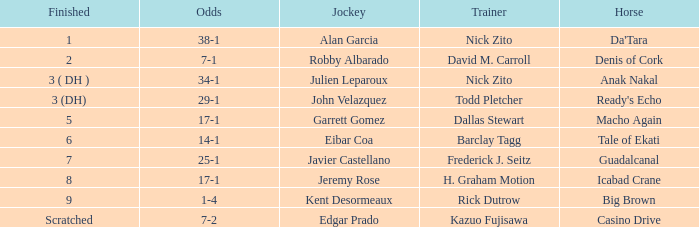What are the Odds for the Horse called Ready's Echo? 29-1. Could you help me parse every detail presented in this table? {'header': ['Finished', 'Odds', 'Jockey', 'Trainer', 'Horse'], 'rows': [['1', '38-1', 'Alan Garcia', 'Nick Zito', "Da'Tara"], ['2', '7-1', 'Robby Albarado', 'David M. Carroll', 'Denis of Cork'], ['3 ( DH )', '34-1', 'Julien Leparoux', 'Nick Zito', 'Anak Nakal'], ['3 (DH)', '29-1', 'John Velazquez', 'Todd Pletcher', "Ready's Echo"], ['5', '17-1', 'Garrett Gomez', 'Dallas Stewart', 'Macho Again'], ['6', '14-1', 'Eibar Coa', 'Barclay Tagg', 'Tale of Ekati'], ['7', '25-1', 'Javier Castellano', 'Frederick J. Seitz', 'Guadalcanal'], ['8', '17-1', 'Jeremy Rose', 'H. Graham Motion', 'Icabad Crane'], ['9', '1-4', 'Kent Desormeaux', 'Rick Dutrow', 'Big Brown'], ['Scratched', '7-2', 'Edgar Prado', 'Kazuo Fujisawa', 'Casino Drive']]} 